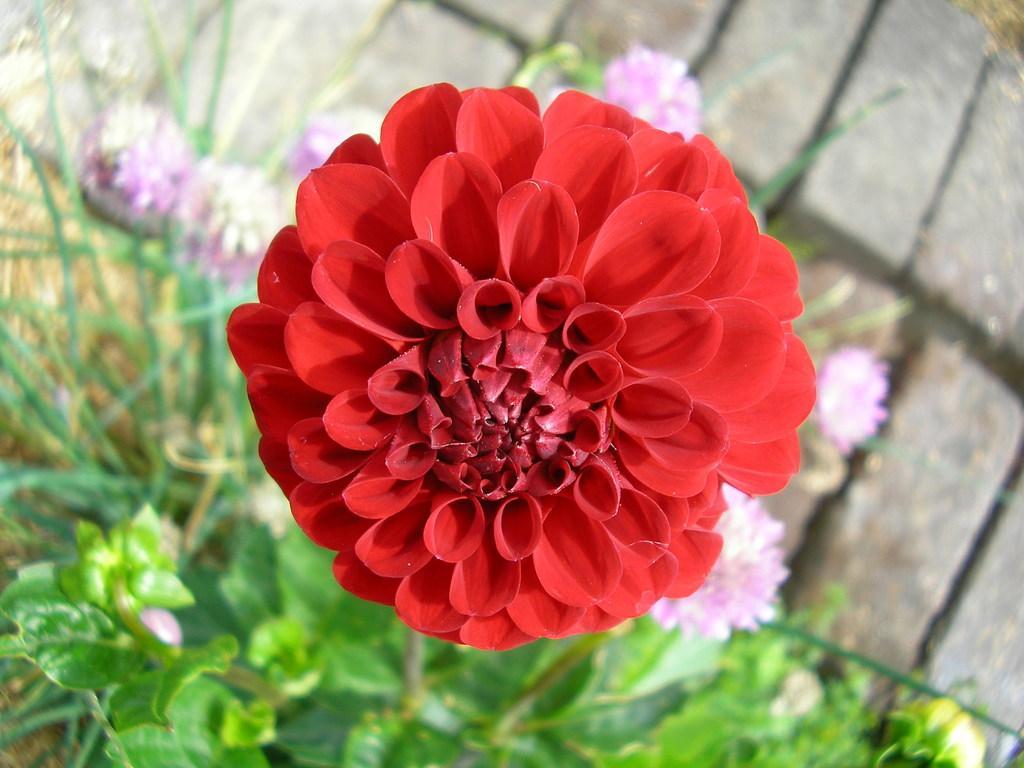In one or two sentences, can you explain what this image depicts? In the image there is a red flower to the plant and around that flower there are some other flowers, the background of the flowers is blur. 